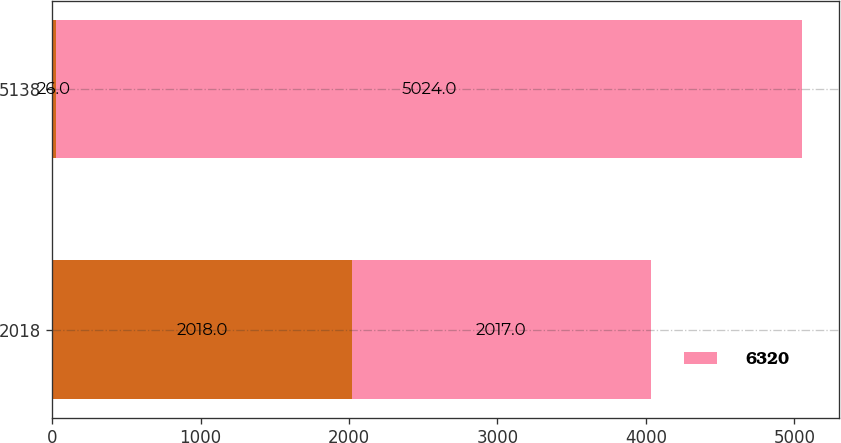Convert chart to OTSL. <chart><loc_0><loc_0><loc_500><loc_500><stacked_bar_chart><ecel><fcel>2018<fcel>5138<nl><fcel>nan<fcel>2018<fcel>26<nl><fcel>6320<fcel>2017<fcel>5024<nl></chart> 